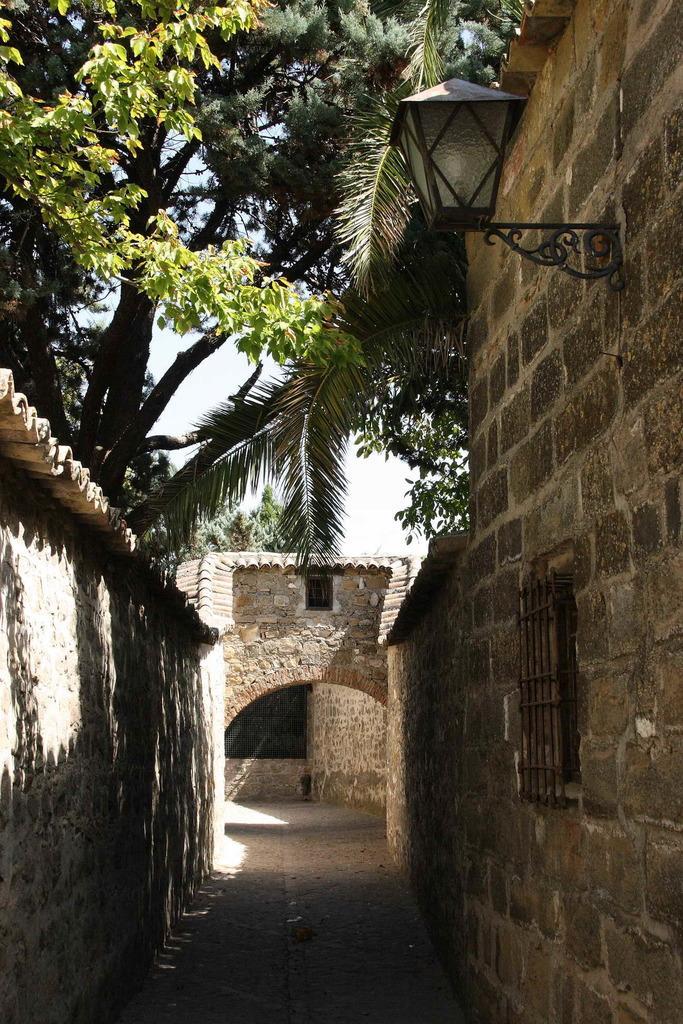In one or two sentences, can you explain what this image depicts? In this image we can see a building with the windows and a roof. We can also see a metal grill, a street lamp, some trees and the sky. 